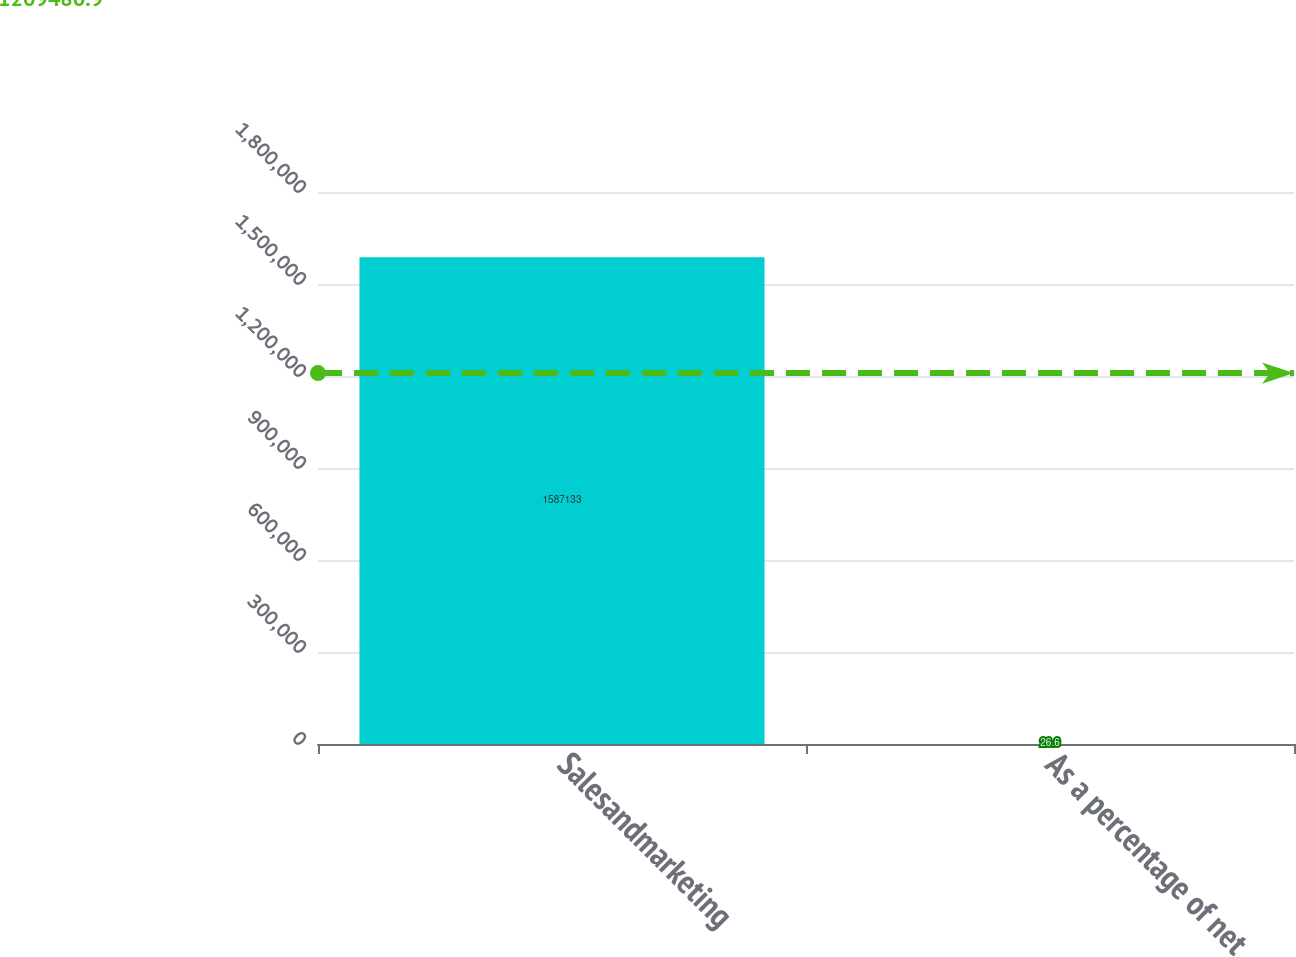Convert chart to OTSL. <chart><loc_0><loc_0><loc_500><loc_500><bar_chart><fcel>Salesandmarketing<fcel>As a percentage of net<nl><fcel>1.58713e+06<fcel>26.6<nl></chart> 